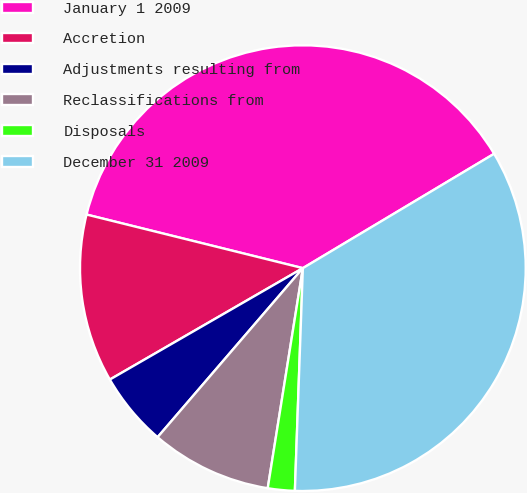Convert chart to OTSL. <chart><loc_0><loc_0><loc_500><loc_500><pie_chart><fcel>January 1 2009<fcel>Accretion<fcel>Adjustments resulting from<fcel>Reclassifications from<fcel>Disposals<fcel>December 31 2009<nl><fcel>37.56%<fcel>12.2%<fcel>5.37%<fcel>8.78%<fcel>1.95%<fcel>34.15%<nl></chart> 